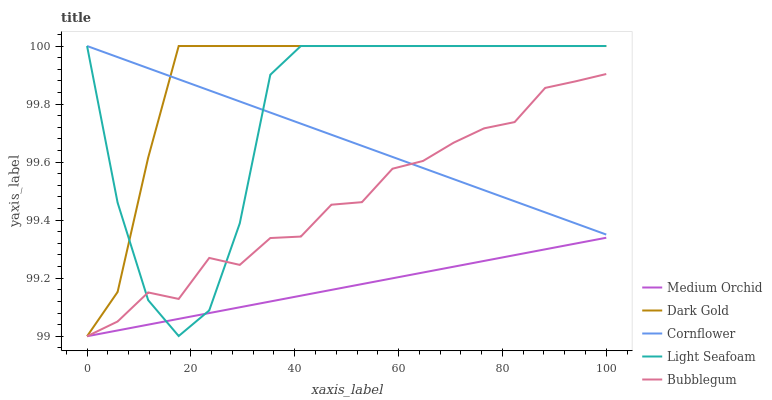Does Medium Orchid have the minimum area under the curve?
Answer yes or no. Yes. Does Dark Gold have the maximum area under the curve?
Answer yes or no. Yes. Does Bubblegum have the minimum area under the curve?
Answer yes or no. No. Does Bubblegum have the maximum area under the curve?
Answer yes or no. No. Is Cornflower the smoothest?
Answer yes or no. Yes. Is Light Seafoam the roughest?
Answer yes or no. Yes. Is Medium Orchid the smoothest?
Answer yes or no. No. Is Medium Orchid the roughest?
Answer yes or no. No. Does Medium Orchid have the lowest value?
Answer yes or no. Yes. Does Light Seafoam have the lowest value?
Answer yes or no. No. Does Dark Gold have the highest value?
Answer yes or no. Yes. Does Bubblegum have the highest value?
Answer yes or no. No. Is Bubblegum less than Dark Gold?
Answer yes or no. Yes. Is Cornflower greater than Medium Orchid?
Answer yes or no. Yes. Does Cornflower intersect Bubblegum?
Answer yes or no. Yes. Is Cornflower less than Bubblegum?
Answer yes or no. No. Is Cornflower greater than Bubblegum?
Answer yes or no. No. Does Bubblegum intersect Dark Gold?
Answer yes or no. No. 